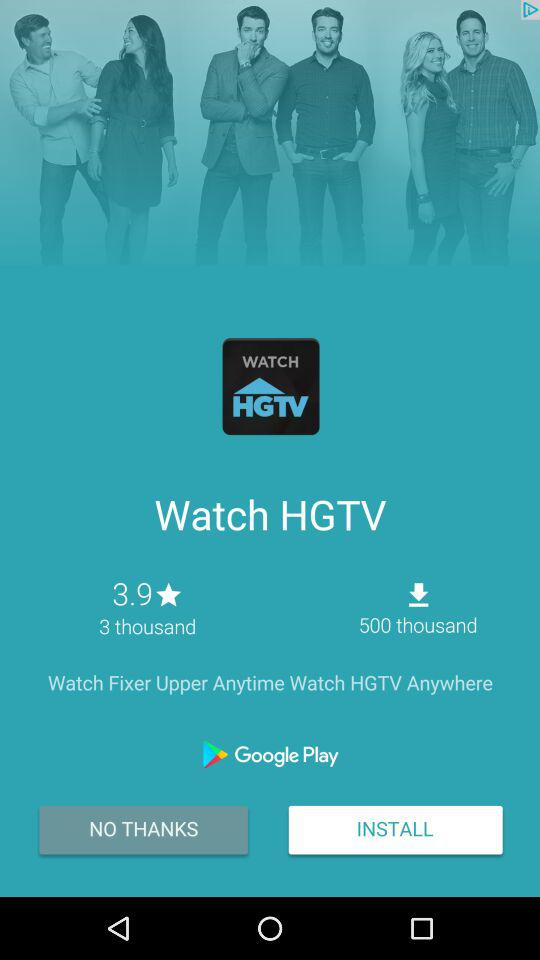How many more downloads does the app have than reviews?
Answer the question using a single word or phrase. 497 thousand 